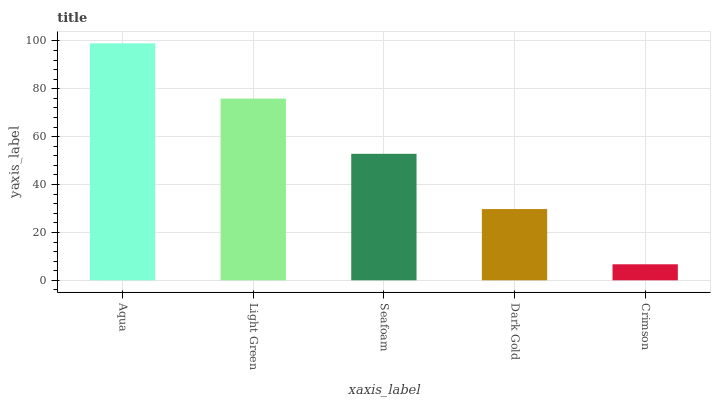Is Light Green the minimum?
Answer yes or no. No. Is Light Green the maximum?
Answer yes or no. No. Is Aqua greater than Light Green?
Answer yes or no. Yes. Is Light Green less than Aqua?
Answer yes or no. Yes. Is Light Green greater than Aqua?
Answer yes or no. No. Is Aqua less than Light Green?
Answer yes or no. No. Is Seafoam the high median?
Answer yes or no. Yes. Is Seafoam the low median?
Answer yes or no. Yes. Is Dark Gold the high median?
Answer yes or no. No. Is Dark Gold the low median?
Answer yes or no. No. 